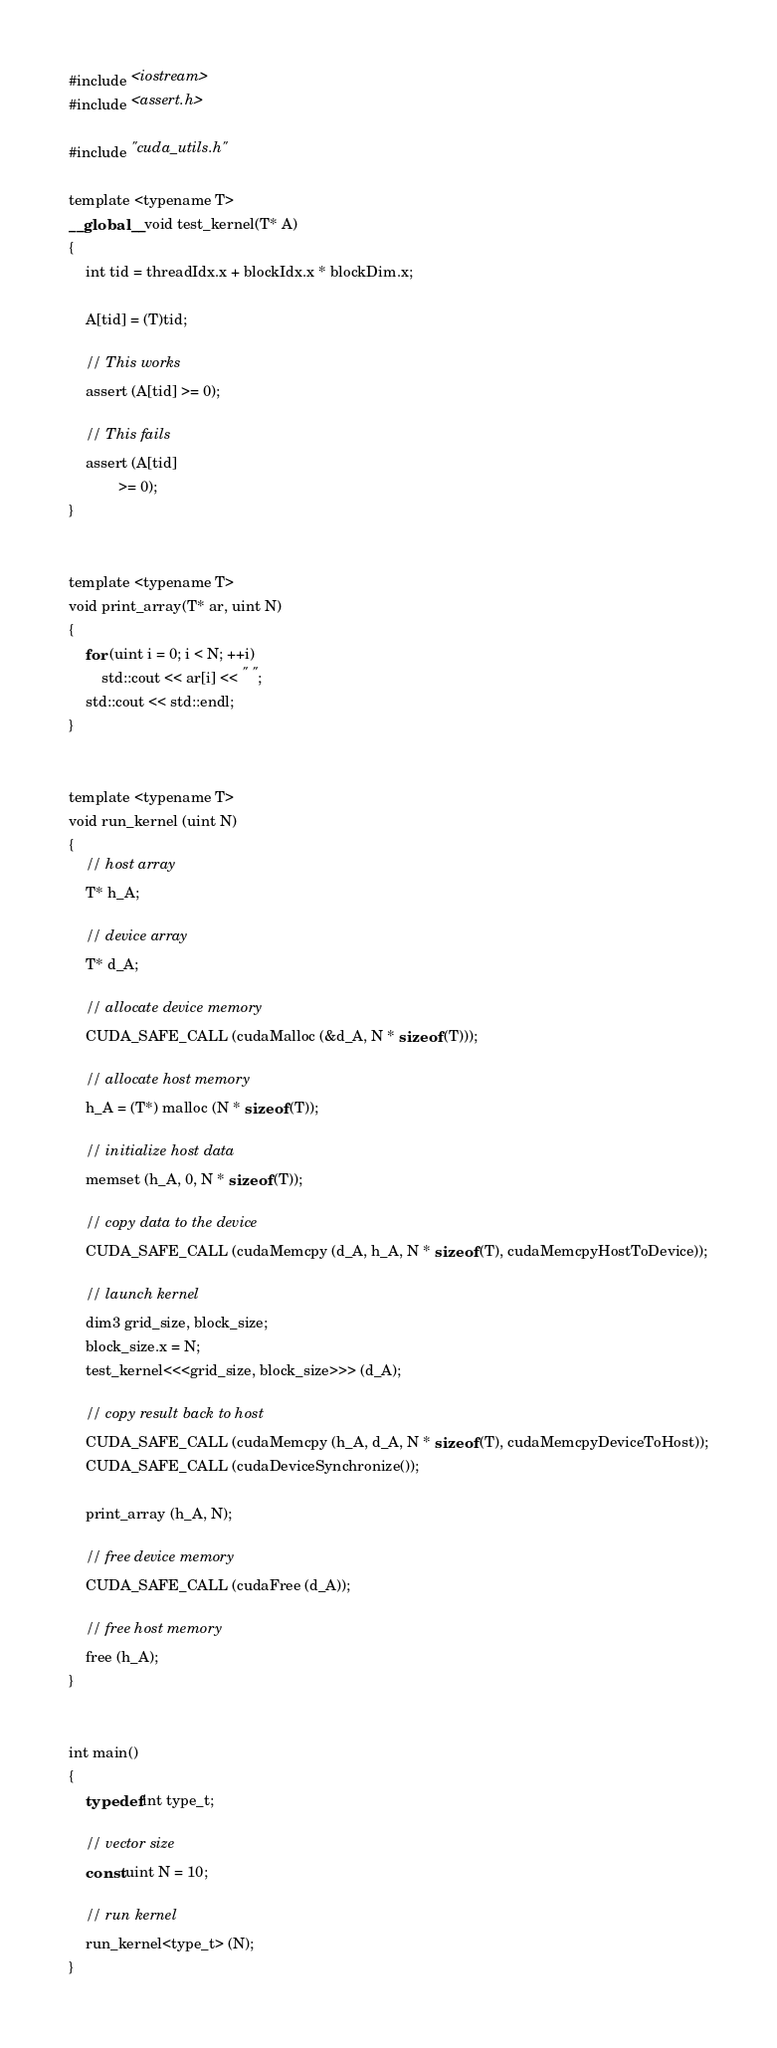<code> <loc_0><loc_0><loc_500><loc_500><_Cuda_>#include <iostream>
#include <assert.h>

#include "cuda_utils.h"

template <typename T>
__global__ void test_kernel(T* A)
{
    int tid = threadIdx.x + blockIdx.x * blockDim.x;

    A[tid] = (T)tid;

    // This works
    assert (A[tid] >= 0);

    // This fails
    assert (A[tid]
            >= 0);
}


template <typename T>
void print_array(T* ar, uint N)
{
    for (uint i = 0; i < N; ++i)
        std::cout << ar[i] << " ";
    std::cout << std::endl;
}


template <typename T>
void run_kernel (uint N)
{
    // host array
    T* h_A;

    // device array
    T* d_A;

    // allocate device memory
    CUDA_SAFE_CALL (cudaMalloc (&d_A, N * sizeof (T)));

    // allocate host memory
    h_A = (T*) malloc (N * sizeof (T));

    // initialize host data
    memset (h_A, 0, N * sizeof (T));

    // copy data to the device
    CUDA_SAFE_CALL (cudaMemcpy (d_A, h_A, N * sizeof (T), cudaMemcpyHostToDevice));

    // launch kernel
    dim3 grid_size, block_size;
    block_size.x = N;
    test_kernel<<<grid_size, block_size>>> (d_A);

    // copy result back to host
    CUDA_SAFE_CALL (cudaMemcpy (h_A, d_A, N * sizeof (T), cudaMemcpyDeviceToHost));
    CUDA_SAFE_CALL (cudaDeviceSynchronize());

    print_array (h_A, N);

    // free device memory
    CUDA_SAFE_CALL (cudaFree (d_A));

    // free host memory
    free (h_A);
}


int main()
{
    typedef int type_t;

    // vector size
    const uint N = 10;

    // run kernel
    run_kernel<type_t> (N);
}
</code> 